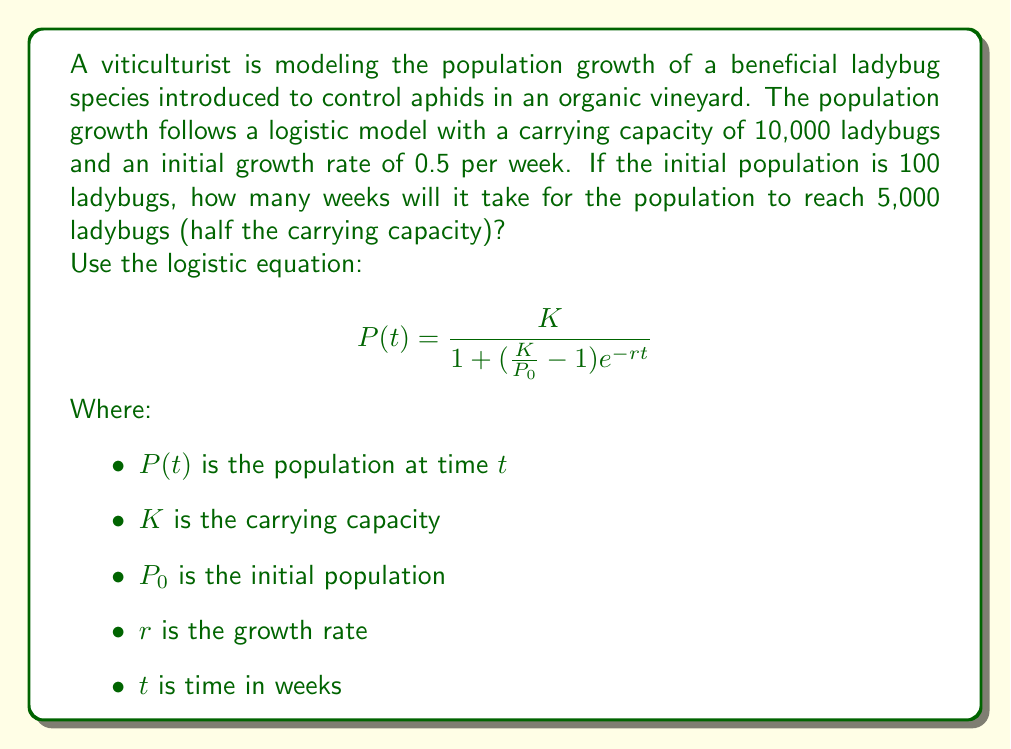Solve this math problem. To solve this problem, we'll use the logistic equation and solve for $t$ when $P(t) = 5,000$.

Given:
$K = 10,000$
$P_0 = 100$
$r = 0.5$
$P(t) = 5,000$

Step 1: Substitute the known values into the logistic equation:

$$5,000 = \frac{10,000}{1 + (\frac{10,000}{100} - 1)e^{-0.5t}}$$

Step 2: Simplify:

$$5,000 = \frac{10,000}{1 + 99e^{-0.5t}}$$

Step 3: Multiply both sides by $(1 + 99e^{-0.5t})$:

$$5,000(1 + 99e^{-0.5t}) = 10,000$$

Step 4: Expand:

$$5,000 + 495,000e^{-0.5t} = 10,000$$

Step 5: Subtract 5,000 from both sides:

$$495,000e^{-0.5t} = 5,000$$

Step 6: Divide both sides by 495,000:

$$e^{-0.5t} = \frac{1}{99}$$

Step 7: Take the natural logarithm of both sides:

$$-0.5t = \ln(\frac{1}{99})$$

Step 8: Solve for $t$:

$$t = -\frac{2\ln(\frac{1}{99})}{0.5} = 2\ln(99) \approx 9.21$$

Therefore, it will take approximately 9.21 weeks for the ladybug population to reach 5,000.
Answer: 9.21 weeks 